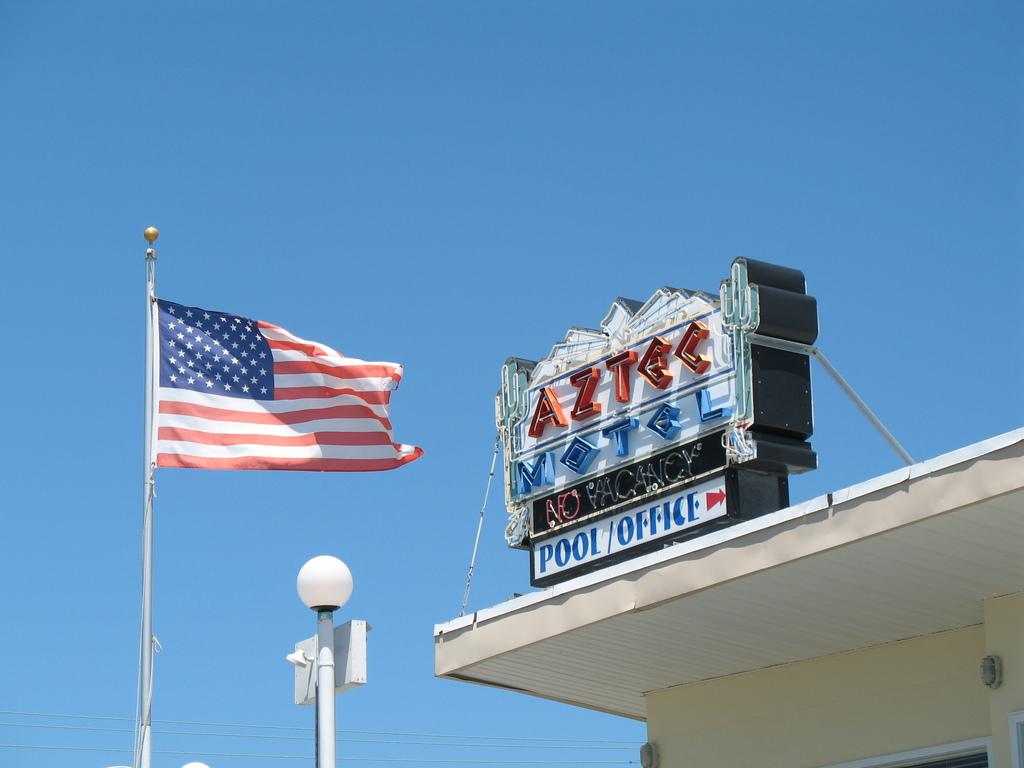What is the main subject of the image? The main subject of the image is a name board to a building. What else can be seen in the image besides the name board? There is a street pole and a flag visible in the image. What is visible in the background of the image? The sky is visible in the image. How many wrens are perched on the street pole in the image? There are no wrens present in the image; it only features a street pole, a flag, and a name board to a building. 